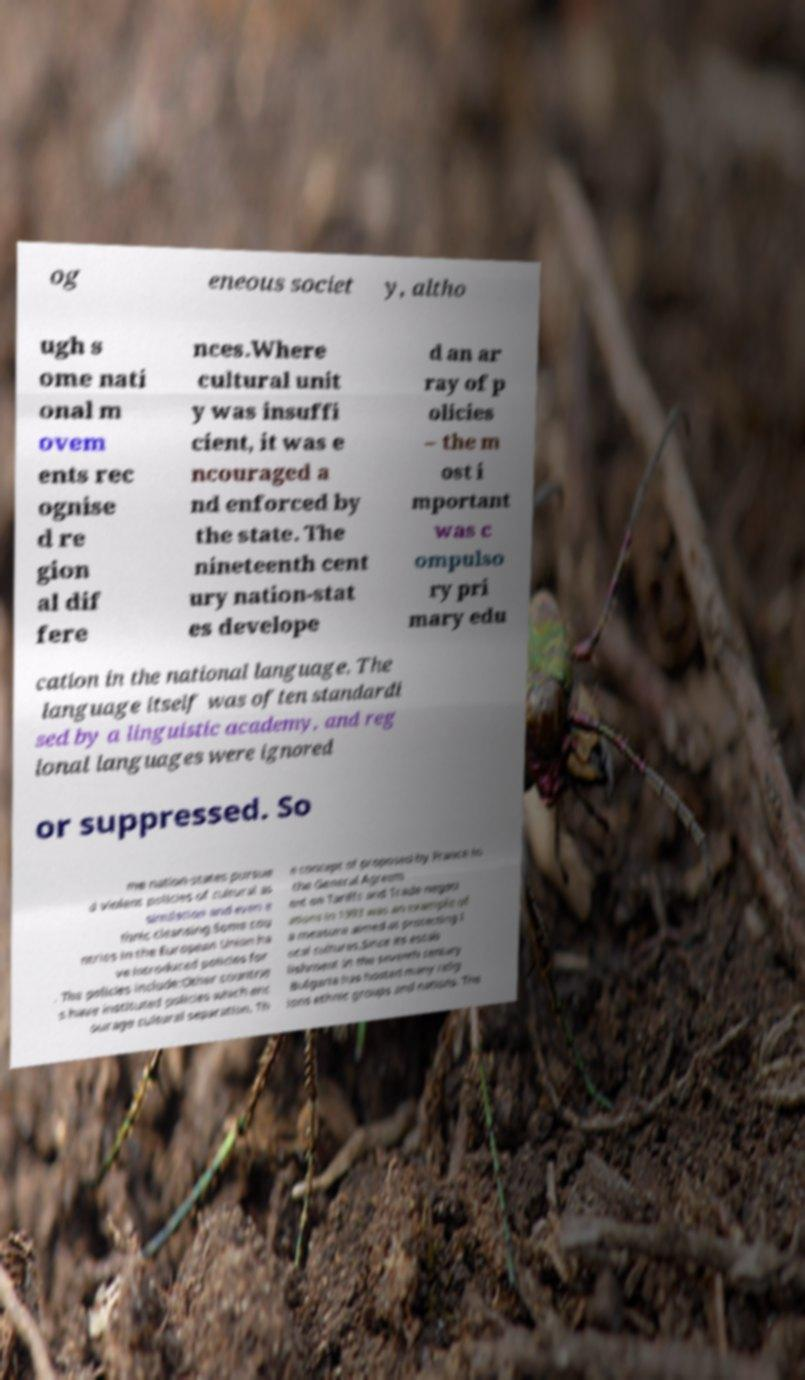Can you read and provide the text displayed in the image?This photo seems to have some interesting text. Can you extract and type it out for me? og eneous societ y, altho ugh s ome nati onal m ovem ents rec ognise d re gion al dif fere nces.Where cultural unit y was insuffi cient, it was e ncouraged a nd enforced by the state. The nineteenth cent ury nation-stat es develope d an ar ray of p olicies – the m ost i mportant was c ompulso ry pri mary edu cation in the national language. The language itself was often standardi sed by a linguistic academy, and reg ional languages were ignored or suppressed. So me nation-states pursue d violent policies of cultural as similation and even e thnic cleansing.Some cou ntries in the European Union ha ve introduced policies for . The policies include:Other countrie s have instituted policies which enc ourage cultural separation. Th e concept of proposed by France in the General Agreem ent on Tariffs and Trade negoti ations in 1993 was an example of a measure aimed at protecting l ocal cultures.Since its estab lishment in the seventh century Bulgaria has hosted many relig ions ethnic groups and nations. The 